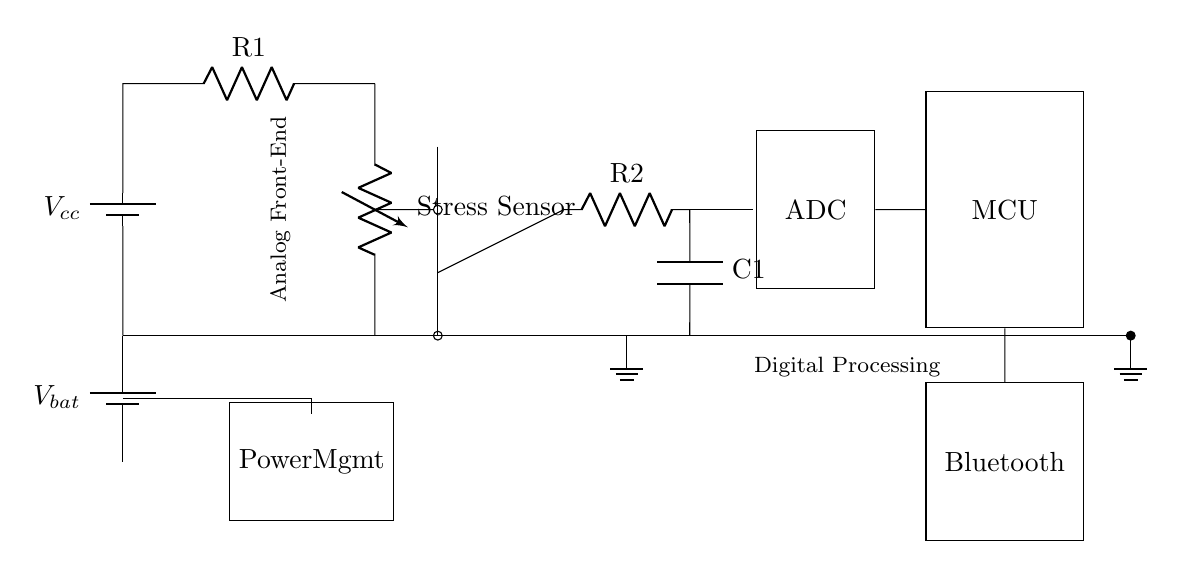What is the function of the stress sensor in the circuit? The stress sensor acts as a variable resistor that changes resistance based on the stress level of the user, allowing the circuit to monitor stress levels.
Answer: variable resistor What type of signal processing is performed by the op-amp? The op-amp amplifies the analog signal coming from the stress sensor so that it can be analyzed more effectively by later stages of the circuit.
Answer: signal amplification Which component converts the analog signal to digital? The ADC (Analog-to-Digital Converter) converts the amplified analog signal from the low-pass filter into a digital signal for further processing.
Answer: ADC What role does the microcontroller play in this circuit? The microcontroller processes the digital signal from the ADC, analyzes the stress data, and manages communication with other components like the Bluetooth module.
Answer: data processing What is the purpose of the Bluetooth module in this hybrid circuit? The Bluetooth module allows the processed data from the microcontroller to be transmitted wirelessly to other devices, such as a smartphone or computer.
Answer: wireless communication What is the value of the supply voltage indicated for the circuit? The circuit diagram does not specify an exact value, but generally, such circuits use a standard supply voltage like 5V or 3.3V for operation.
Answer: unspecified What is the purpose of the low-pass filter in the circuit? The low-pass filter smooths out the amplified signal from the op-amp by removing high-frequency noise, resulting in a cleaner signal for the ADC.
Answer: noise reduction 